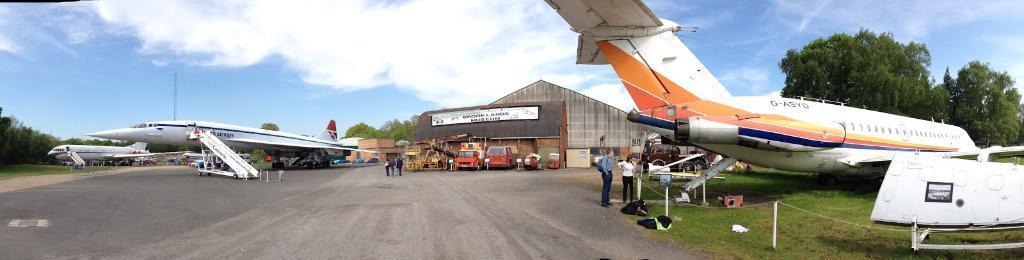In one or two sentences, can you explain what this image depicts? In this image on the right side there is an airplane which is white in colour with some text written on it and there is grass on the ground, there are trees and there are persons standing and there is a pole and there is an object which is white in colour. In the background there are vehicles, there are sheds and on the wall of the shed there is some text written on it. There are persons, there is a house and there are airplanes, trees the sky is cloudy 